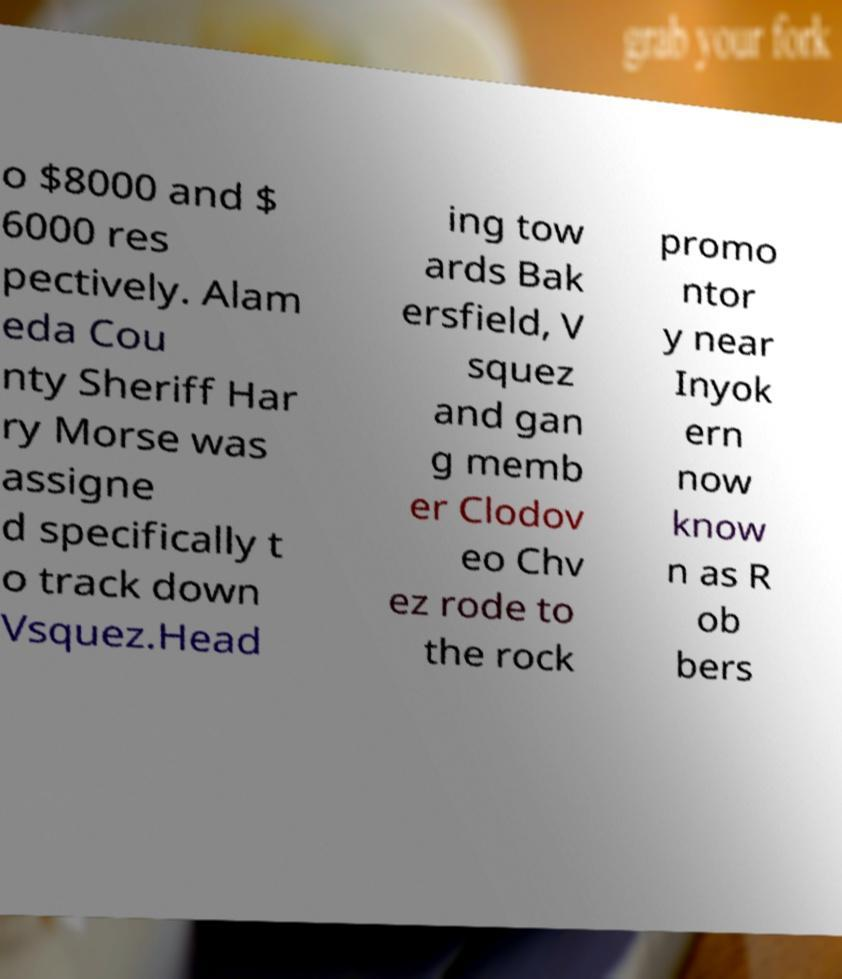There's text embedded in this image that I need extracted. Can you transcribe it verbatim? o $8000 and $ 6000 res pectively. Alam eda Cou nty Sheriff Har ry Morse was assigne d specifically t o track down Vsquez.Head ing tow ards Bak ersfield, V squez and gan g memb er Clodov eo Chv ez rode to the rock promo ntor y near Inyok ern now know n as R ob bers 